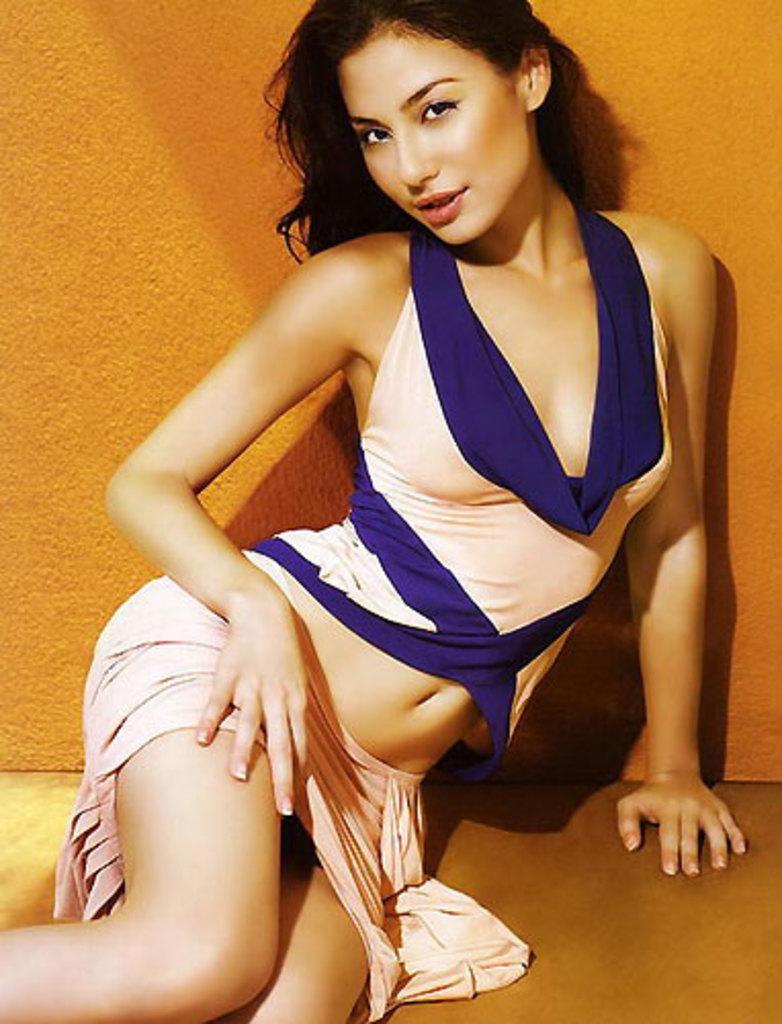Describe this image in one or two sentences. In this picture there is a woman sitting. At the back there is a wall. At the bottom there is a floor. 